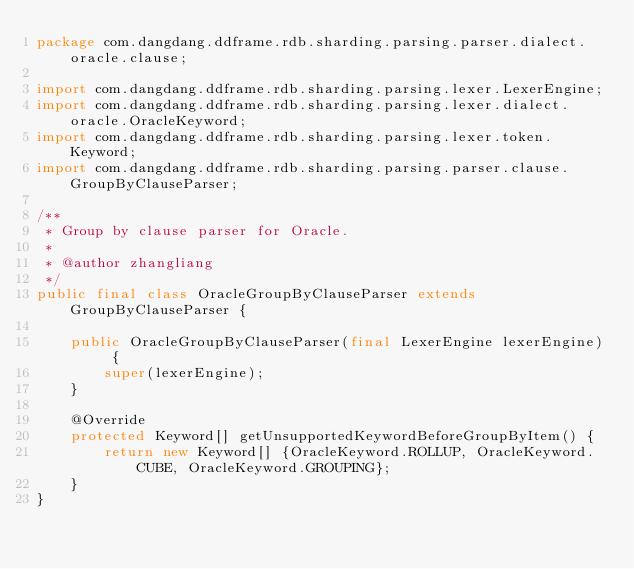Convert code to text. <code><loc_0><loc_0><loc_500><loc_500><_Java_>package com.dangdang.ddframe.rdb.sharding.parsing.parser.dialect.oracle.clause;

import com.dangdang.ddframe.rdb.sharding.parsing.lexer.LexerEngine;
import com.dangdang.ddframe.rdb.sharding.parsing.lexer.dialect.oracle.OracleKeyword;
import com.dangdang.ddframe.rdb.sharding.parsing.lexer.token.Keyword;
import com.dangdang.ddframe.rdb.sharding.parsing.parser.clause.GroupByClauseParser;

/**
 * Group by clause parser for Oracle.
 *
 * @author zhangliang
 */
public final class OracleGroupByClauseParser extends GroupByClauseParser {
    
    public OracleGroupByClauseParser(final LexerEngine lexerEngine) {
        super(lexerEngine);
    }
    
    @Override
    protected Keyword[] getUnsupportedKeywordBeforeGroupByItem() {
        return new Keyword[] {OracleKeyword.ROLLUP, OracleKeyword.CUBE, OracleKeyword.GROUPING};
    }
}
</code> 